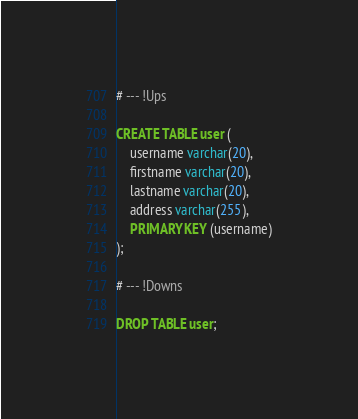Convert code to text. <code><loc_0><loc_0><loc_500><loc_500><_SQL_># --- !Ups
 
CREATE TABLE user (
    username varchar(20),
    firstname varchar(20),
    lastname varchar(20),
    address varchar(255),
    PRIMARY KEY (username)
);
 
# --- !Downs
 
DROP TABLE user;</code> 